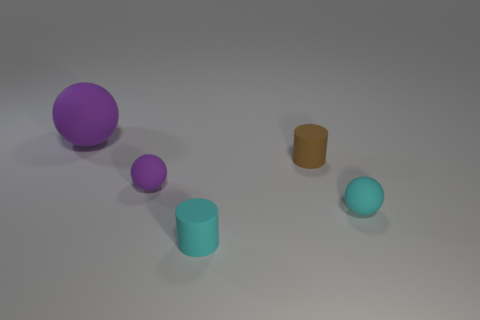Can you describe the colors of the objects? Certainly! In the image, we have objects in shades of purple, cyan, and a single object in a brownish tone. Which colors are paired with which shapes? The two purple objects are spheres, the two cyan objects include one sphere and one cylinder, and the brown object is a short cylinder. 